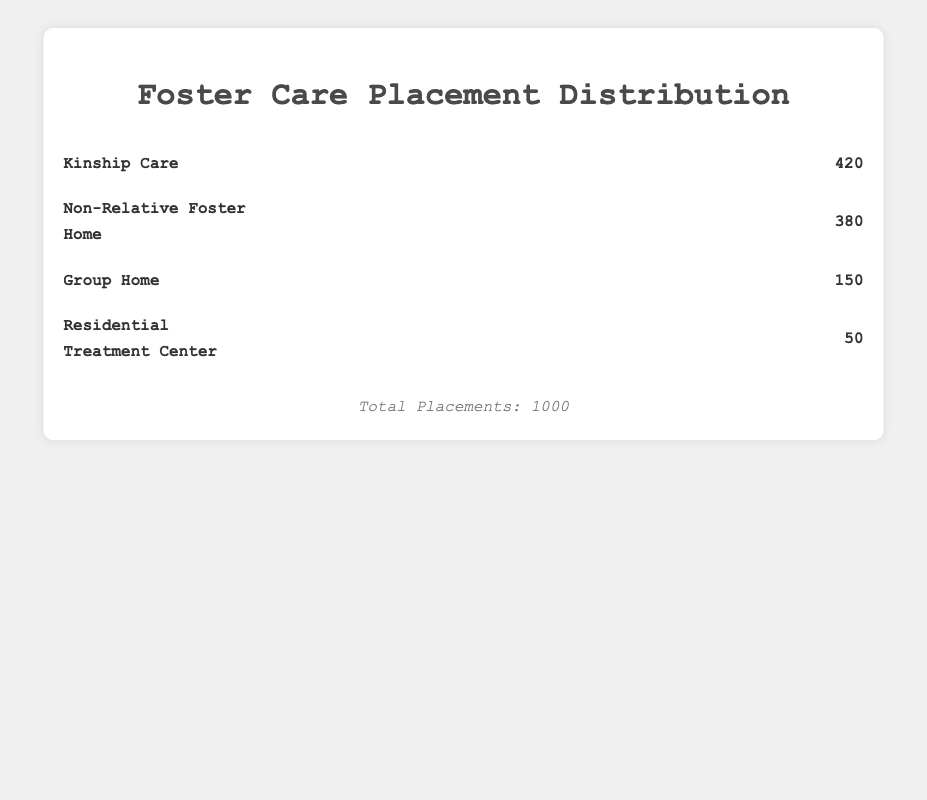What is the total number of foster care placements shown in the plot? Look at the footer of the plot, which mentions the total number of placements.
Answer: 1000 Which type of foster care placement has the highest count? The largest number of icons and the highest count label will indicate the placement with the highest count. Kinship Care has the most icons and a count of 420.
Answer: Kinship Care What are the counts of Non-Relative Foster Home and Group Home placements combined? Add the counts of Non-Relative Foster Home and Group Home placements. Non-Relative Foster Home has 380 placements and Group Home has 150 placements. 380 + 150 = 530.
Answer: 530 How many more kinship care placements are there compared to group home placements? Subtract the count of Group Home placements from the count of Kinship Care placements. Kinship Care has 420, and Group Home has 150. 420 - 150 = 270.
Answer: 270 What type of placement has the fewest number of foster care placements? The placement type with the least number of icons and the lowest count label will indicate the fewest placements. Residential Treatment Center has the fewest with a count of 50.
Answer: Residential Treatment Center Compare the number of Non-Relative Foster Home placements to Kinship Care placements. Which is greater and by how much? Subtract the count of Non-Relative Foster Home placements from the count of Kinship Care placements. Kinship Care has 420 placements, and Non-Relative Foster Home has 380. 420 - 380 = 40. Kinship Care has more placements than Non-Relative Foster Home by 40.
Answer: Kinship Care by 40 Calculate the average number of placements across all types. Add up the counts of all placement types and divide by the number of types (4). Summing up the counts: 420 (Kinship Care) + 380 (Non-Relative Foster Home) + 150 (Group Home) + 50 (Residential Treatment Center) = 1000. Average = 1000 / 4 = 250.
Answer: 250 If another 20 placements were added to Residential Treatment Center, what would the new total number of placements be? Add 20 to the current count of Residential Treatment Center placements and then sum that with the counts of the other placements. Current count: 50 + 20 = 70. Then: 420 (Kinship Care) + 380 (Non-Relative Foster Home) + 150 (Group Home) + 70 (Residential Treatment Center) = 1020.
Answer: 1020 